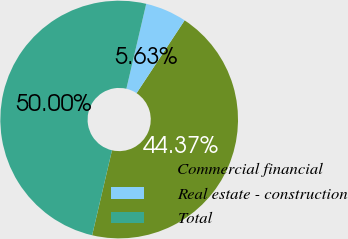Convert chart to OTSL. <chart><loc_0><loc_0><loc_500><loc_500><pie_chart><fcel>Commercial financial<fcel>Real estate - construction<fcel>Total<nl><fcel>44.37%<fcel>5.63%<fcel>50.0%<nl></chart> 